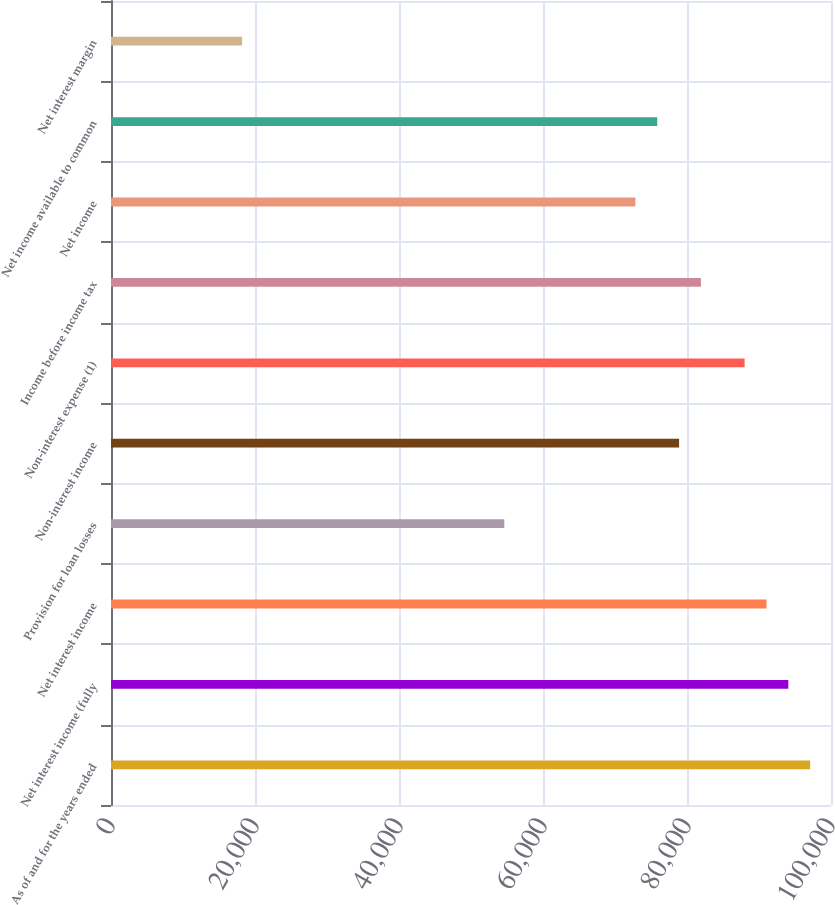Convert chart to OTSL. <chart><loc_0><loc_0><loc_500><loc_500><bar_chart><fcel>As of and for the years ended<fcel>Net interest income (fully<fcel>Net interest income<fcel>Provision for loan losses<fcel>Non-interest income<fcel>Non-interest expense (1)<fcel>Income before income tax<fcel>Net income<fcel>Net income available to common<fcel>Net interest margin<nl><fcel>97106.8<fcel>94072.2<fcel>91037.6<fcel>54622.7<fcel>78899.3<fcel>88003<fcel>81933.9<fcel>72830.1<fcel>75864.7<fcel>18207.7<nl></chart> 